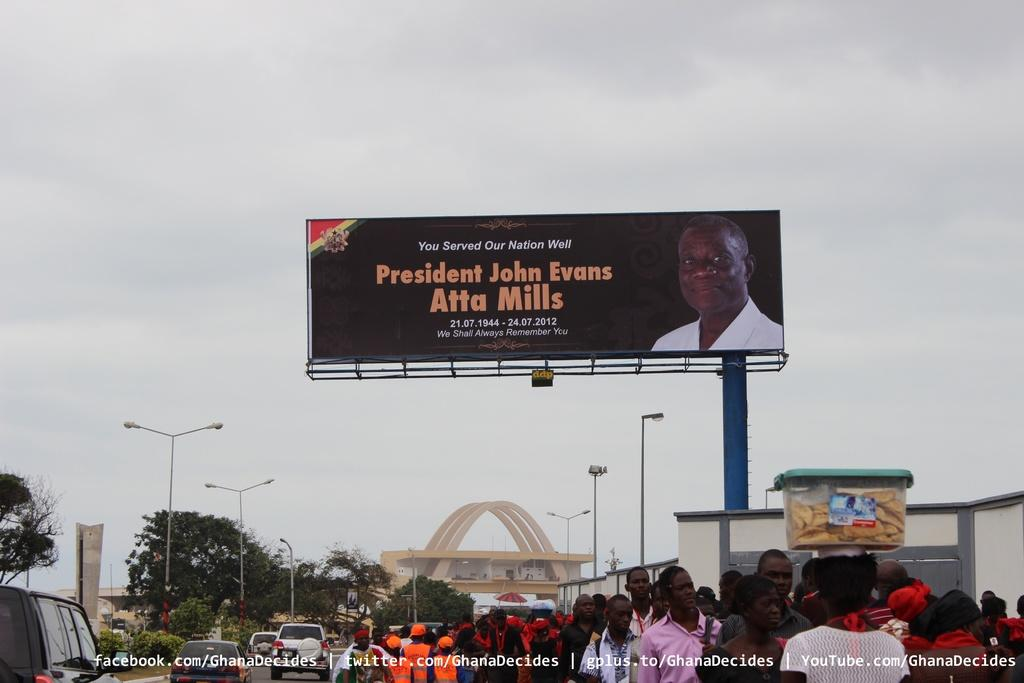Provide a one-sentence caption for the provided image. A billboard for President John Evans stands tall above a crowd. 